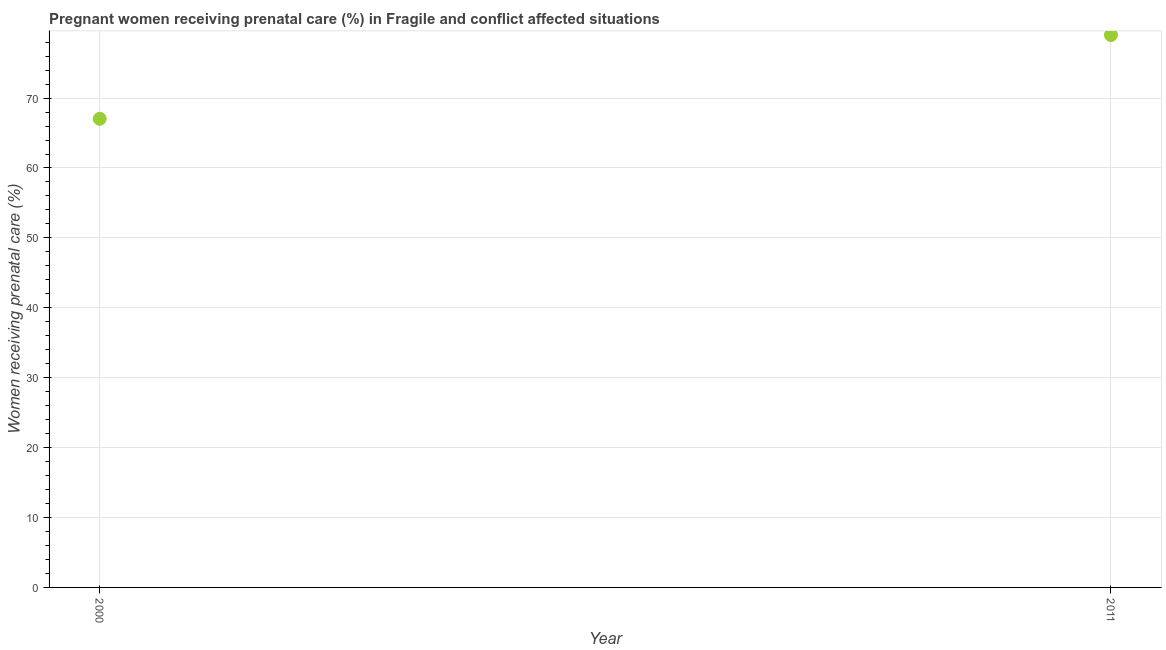What is the percentage of pregnant women receiving prenatal care in 2011?
Your answer should be compact. 79.02. Across all years, what is the maximum percentage of pregnant women receiving prenatal care?
Make the answer very short. 79.02. Across all years, what is the minimum percentage of pregnant women receiving prenatal care?
Give a very brief answer. 67.04. In which year was the percentage of pregnant women receiving prenatal care minimum?
Keep it short and to the point. 2000. What is the sum of the percentage of pregnant women receiving prenatal care?
Provide a succinct answer. 146.06. What is the difference between the percentage of pregnant women receiving prenatal care in 2000 and 2011?
Keep it short and to the point. -11.98. What is the average percentage of pregnant women receiving prenatal care per year?
Provide a succinct answer. 73.03. What is the median percentage of pregnant women receiving prenatal care?
Offer a terse response. 73.03. What is the ratio of the percentage of pregnant women receiving prenatal care in 2000 to that in 2011?
Your response must be concise. 0.85. Is the percentage of pregnant women receiving prenatal care in 2000 less than that in 2011?
Keep it short and to the point. Yes. How many dotlines are there?
Keep it short and to the point. 1. Does the graph contain any zero values?
Give a very brief answer. No. What is the title of the graph?
Offer a very short reply. Pregnant women receiving prenatal care (%) in Fragile and conflict affected situations. What is the label or title of the Y-axis?
Make the answer very short. Women receiving prenatal care (%). What is the Women receiving prenatal care (%) in 2000?
Provide a succinct answer. 67.04. What is the Women receiving prenatal care (%) in 2011?
Give a very brief answer. 79.02. What is the difference between the Women receiving prenatal care (%) in 2000 and 2011?
Keep it short and to the point. -11.98. What is the ratio of the Women receiving prenatal care (%) in 2000 to that in 2011?
Provide a short and direct response. 0.85. 